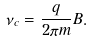<formula> <loc_0><loc_0><loc_500><loc_500>\nu _ { c } = \frac { q } { 2 \pi m } B .</formula> 